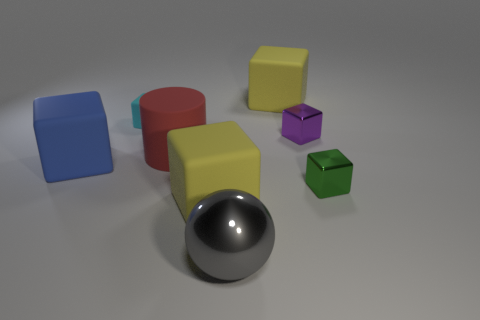Subtract 1 blocks. How many blocks are left? 5 Subtract all purple cubes. How many cubes are left? 5 Subtract all tiny green metallic blocks. How many blocks are left? 5 Subtract all yellow cylinders. Subtract all yellow spheres. How many cylinders are left? 1 Add 1 tiny cyan things. How many objects exist? 9 Subtract all cylinders. How many objects are left? 7 Subtract all tiny red balls. Subtract all big red objects. How many objects are left? 7 Add 7 big red cylinders. How many big red cylinders are left? 8 Add 5 brown spheres. How many brown spheres exist? 5 Subtract 0 brown cylinders. How many objects are left? 8 